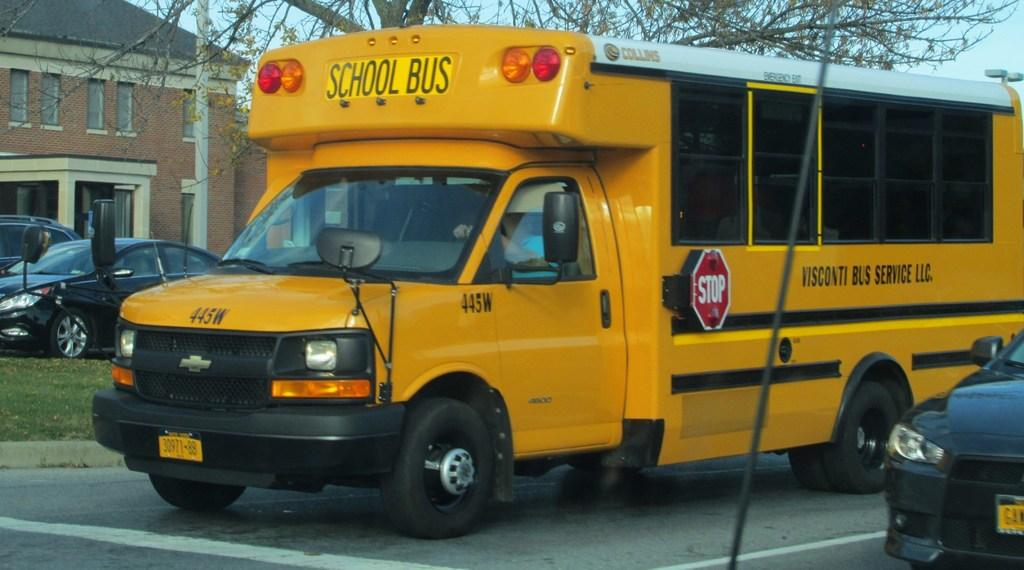<image>
Relay a brief, clear account of the picture shown. A school bus is labeled 445W and is on the street. 